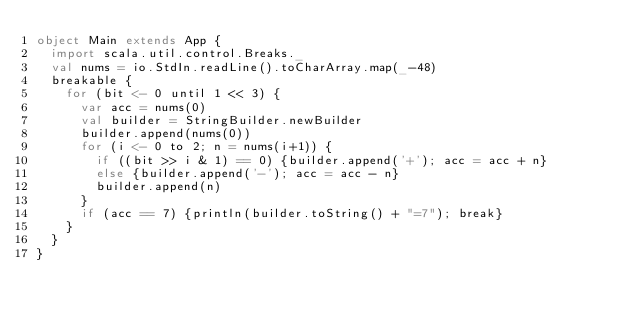Convert code to text. <code><loc_0><loc_0><loc_500><loc_500><_Scala_>object Main extends App {
  import scala.util.control.Breaks._
  val nums = io.StdIn.readLine().toCharArray.map(_-48)
  breakable {
    for (bit <- 0 until 1 << 3) {
      var acc = nums(0)
      val builder = StringBuilder.newBuilder
      builder.append(nums(0))
      for (i <- 0 to 2; n = nums(i+1)) {
        if ((bit >> i & 1) == 0) {builder.append('+'); acc = acc + n}
        else {builder.append('-'); acc = acc - n}
        builder.append(n)
      }
      if (acc == 7) {println(builder.toString() + "=7"); break}
    }
  }
}</code> 